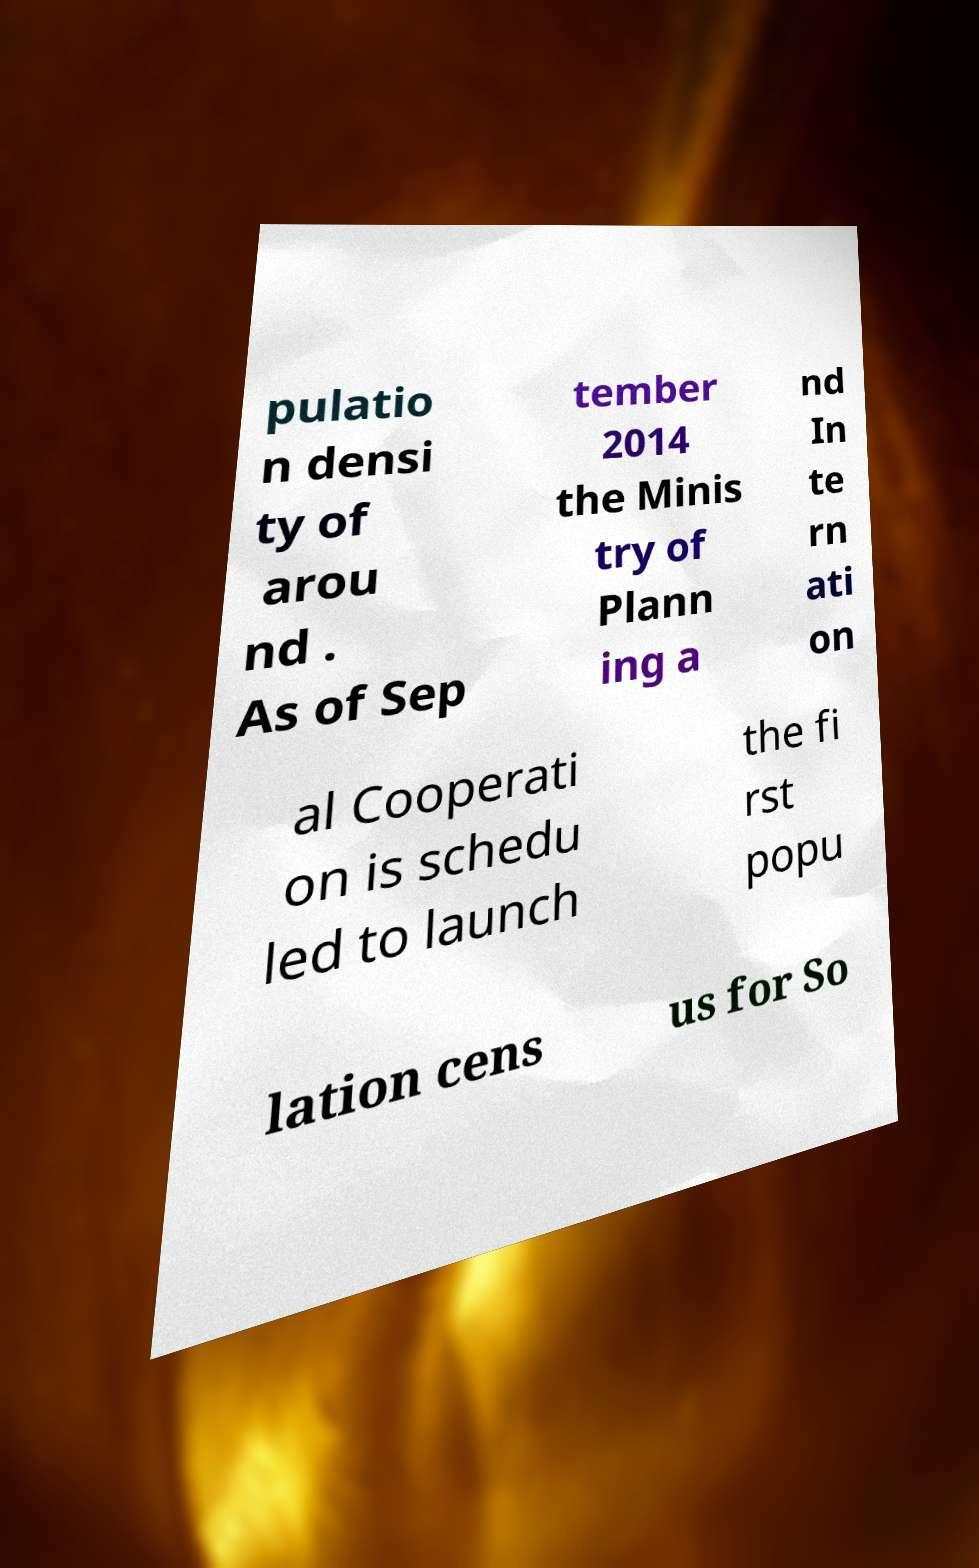Can you read and provide the text displayed in the image?This photo seems to have some interesting text. Can you extract and type it out for me? pulatio n densi ty of arou nd . As of Sep tember 2014 the Minis try of Plann ing a nd In te rn ati on al Cooperati on is schedu led to launch the fi rst popu lation cens us for So 